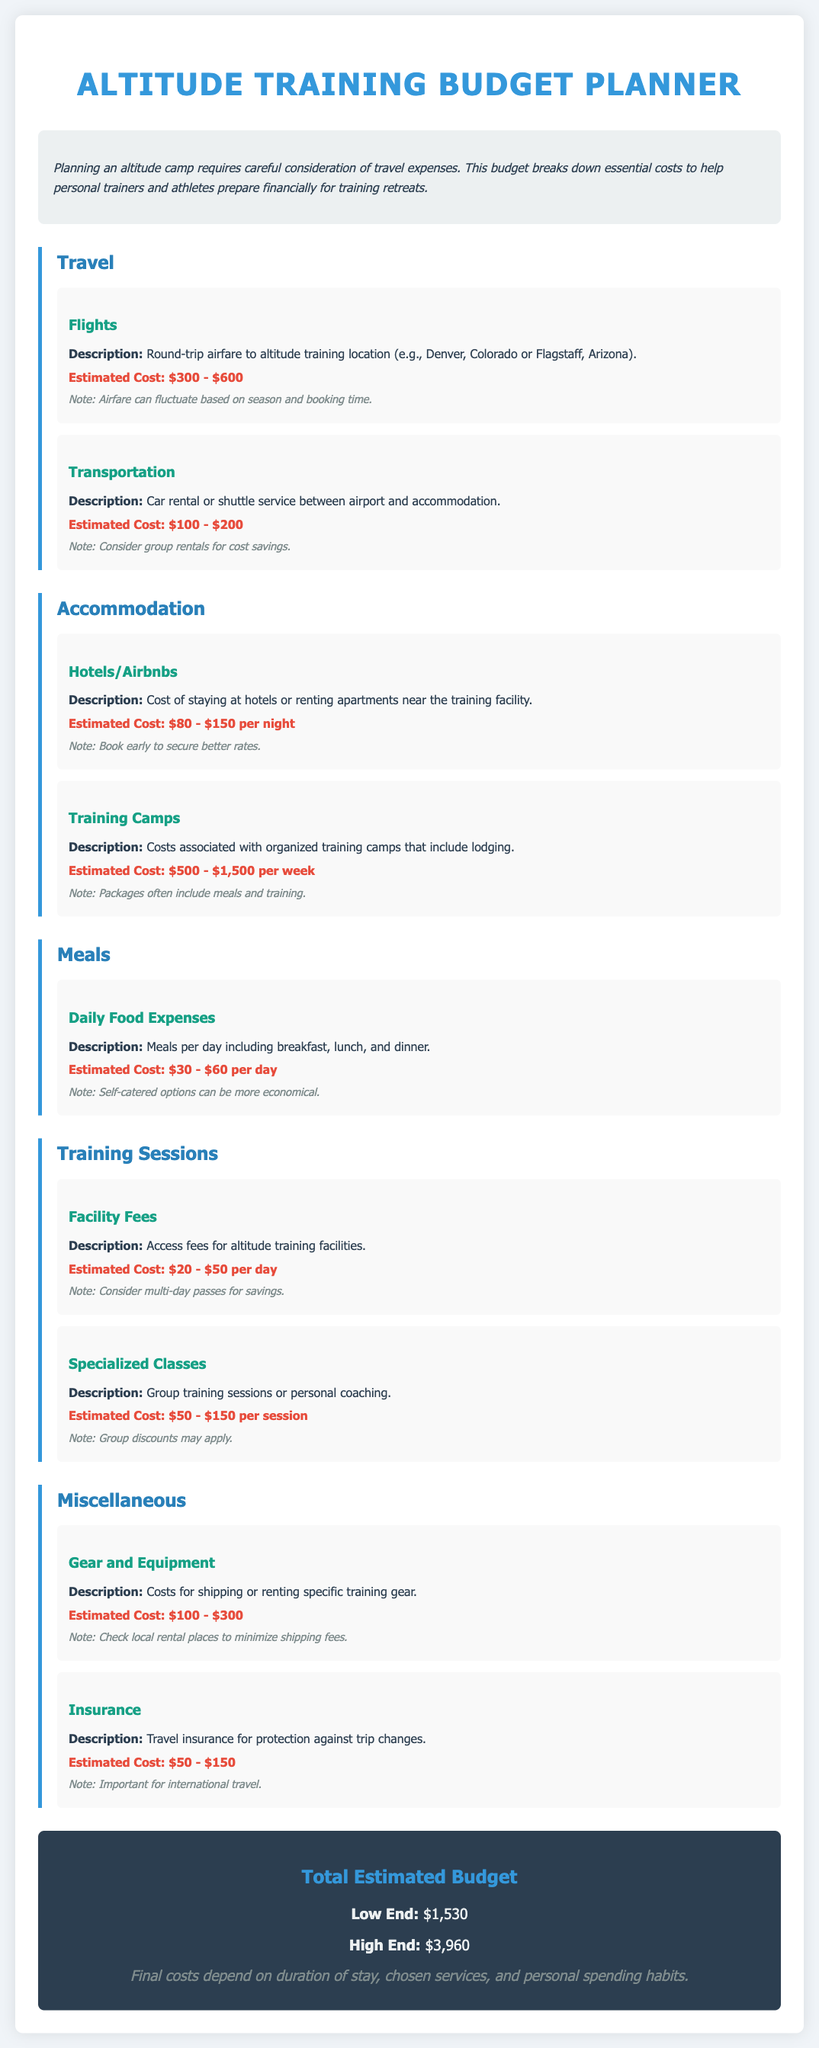What is the estimated cost for flights? The estimated cost for flights ranges from $300 to $600 as mentioned in the Travel section.
Answer: $300 - $600 What type of accommodation is listed in the budget? The budget lists Hotels/Airbnbs as a type of accommodation under the Accommodation section.
Answer: Hotels/Airbnbs How much are daily food expenses estimated to be? The estimated cost for daily food expenses is provided in the Meals section and ranges from $30 to $60 per day.
Answer: $30 - $60 per day What are the estimated facility fees for training sessions? Facility fees are estimated to be $20 to $50 per day as stated in the Training Sessions section.
Answer: $20 - $50 per day What is the total estimated budget for this training plan? The total estimated budget includes a low end and high end amount which are specified in the document.
Answer: $1,530 - $3,960 What is the estimated cost for insurance? The estimated cost for travel insurance ranges from $50 to $150 according to the Miscellaneous section.
Answer: $50 - $150 How can costs be minimized for gear and equipment? The document suggests checking local rental places to minimize shipping fees.
Answer: Check local rental places What is included in the Training Camps costs? The Training Camps costs usually include lodging as mentioned in the Accommodation section.
Answer: Lodging What should be considered for transportation to save costs? The document advises considering group rentals for transportation cost savings.
Answer: Group rentals 